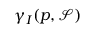Convert formula to latex. <formula><loc_0><loc_0><loc_500><loc_500>\gamma _ { I } ( p , { \mathcal { S } } )</formula> 